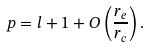<formula> <loc_0><loc_0><loc_500><loc_500>p = l + 1 + O \left ( \frac { r _ { e } } { r _ { c } } \right ) .</formula> 